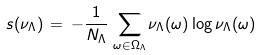Convert formula to latex. <formula><loc_0><loc_0><loc_500><loc_500>s ( \nu _ { \Lambda } ) \, = \, - \frac { 1 } { N _ { \Lambda } } \, \sum _ { \omega \in \Omega _ { \Lambda } } \nu _ { \Lambda } ( \omega ) \log \nu _ { \Lambda } ( \omega )</formula> 